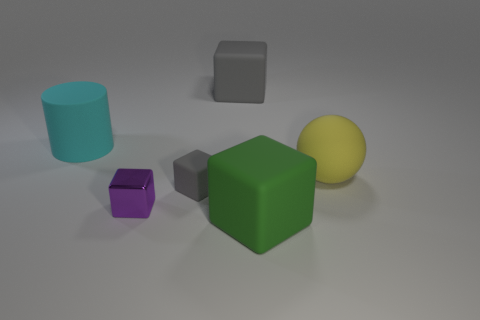What color is the cube that is both right of the purple thing and in front of the tiny gray matte cube? The cube that is positioned to the right of the purple object and in front of the small, gray matte cube is green. It has a solid and visibly matte surface, contrasting with the shinier textures of some other objects in the scene. 